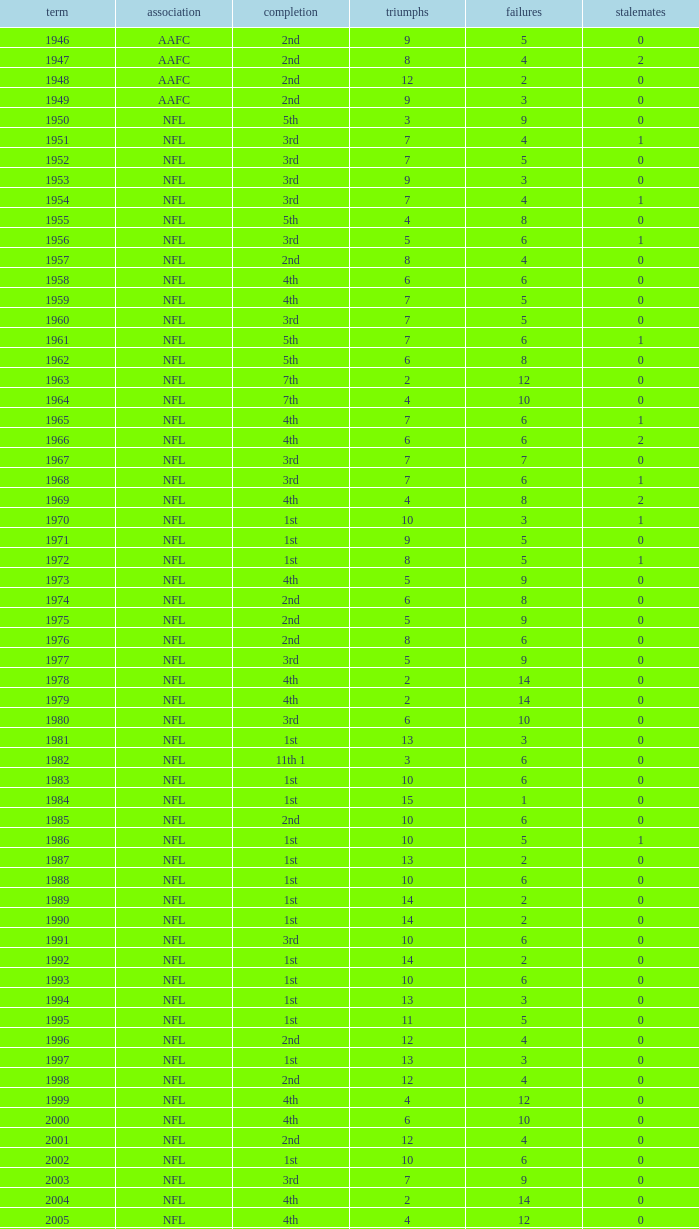What is the number of losses when the ties are lesser than 0? 0.0. 